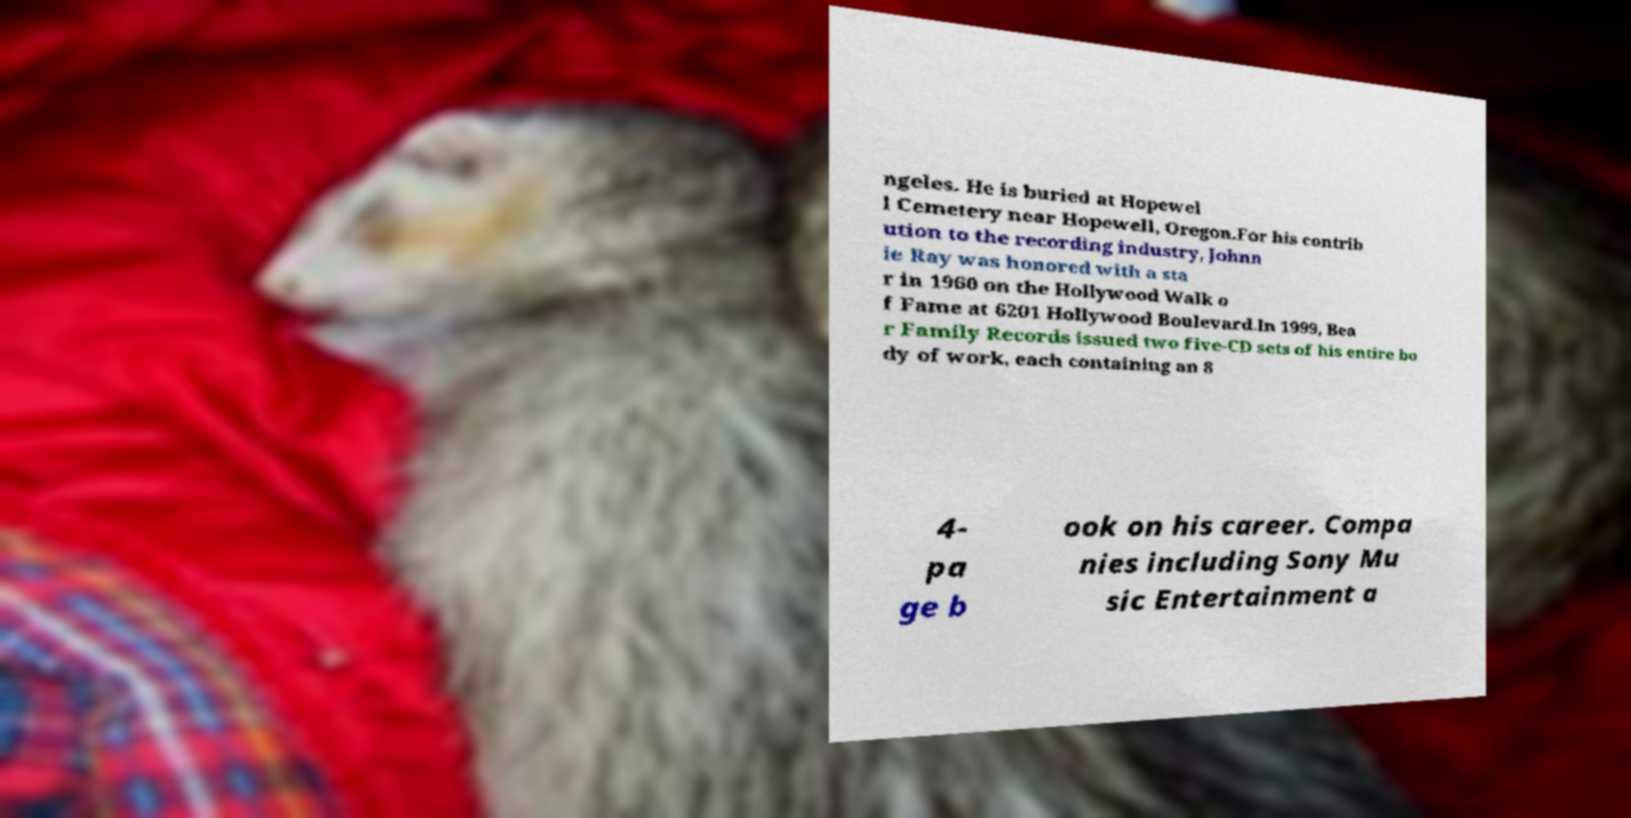Can you read and provide the text displayed in the image?This photo seems to have some interesting text. Can you extract and type it out for me? ngeles. He is buried at Hopewel l Cemetery near Hopewell, Oregon.For his contrib ution to the recording industry, Johnn ie Ray was honored with a sta r in 1960 on the Hollywood Walk o f Fame at 6201 Hollywood Boulevard.In 1999, Bea r Family Records issued two five-CD sets of his entire bo dy of work, each containing an 8 4- pa ge b ook on his career. Compa nies including Sony Mu sic Entertainment a 